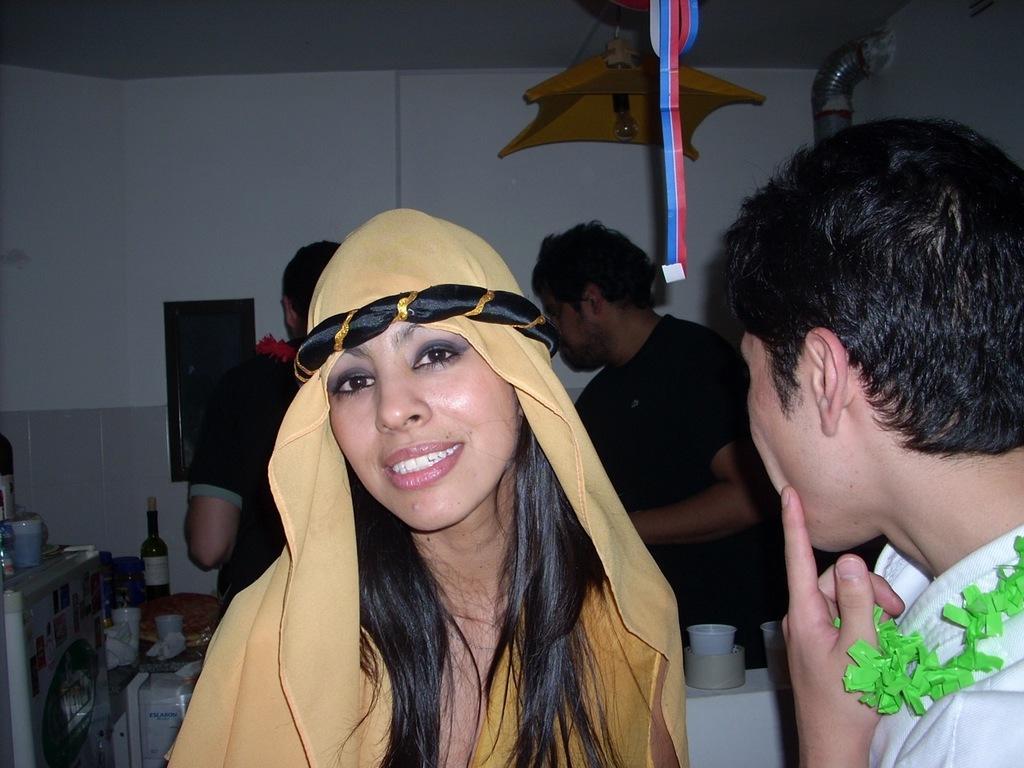Can you describe this image briefly? In this image I can see few people are standing and wearing different color dresses. Back I can see a bottle, cups, tissues and few objects on the table. I can see a pipe, light and the wall. 